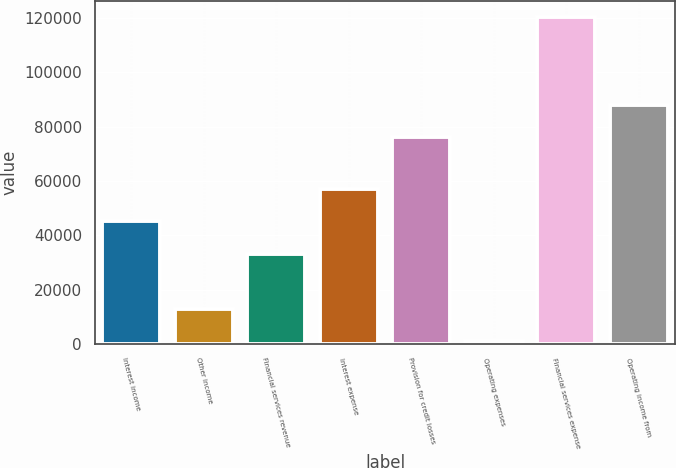Convert chart to OTSL. <chart><loc_0><loc_0><loc_500><loc_500><bar_chart><fcel>Interest income<fcel>Other income<fcel>Financial services revenue<fcel>Interest expense<fcel>Provision for credit losses<fcel>Operating expenses<fcel>Financial services expense<fcel>Operating income from<nl><fcel>45167.9<fcel>13006.9<fcel>33260<fcel>57075.8<fcel>76087<fcel>1099<fcel>120178<fcel>87994.9<nl></chart> 